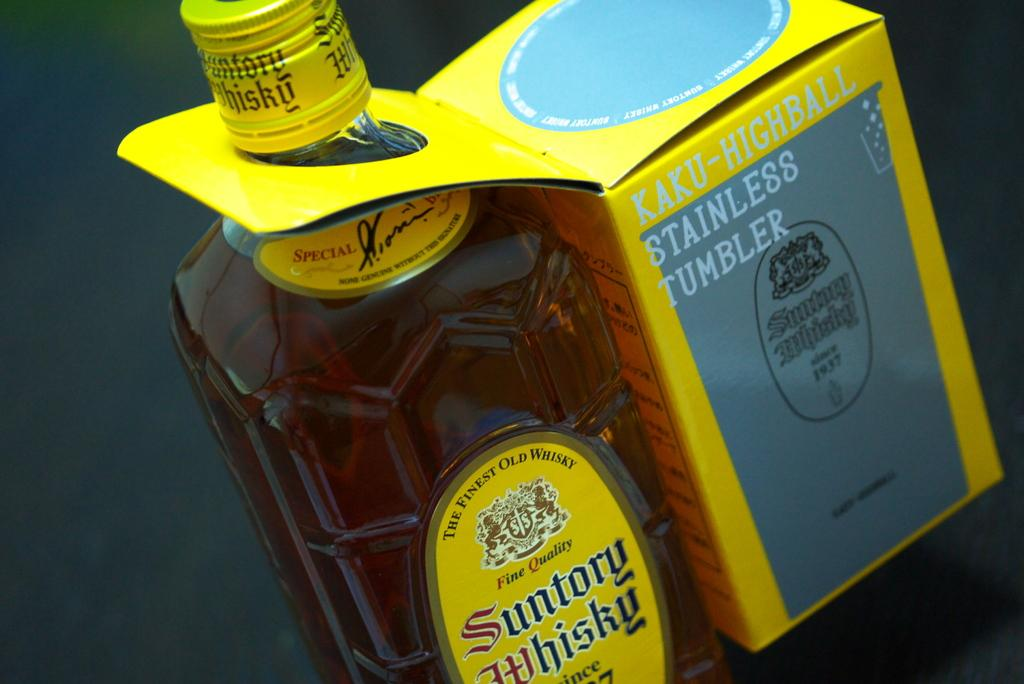<image>
Create a compact narrative representing the image presented. a bottle of suntory whiskey sitting next to a box with a stainless tumbler 